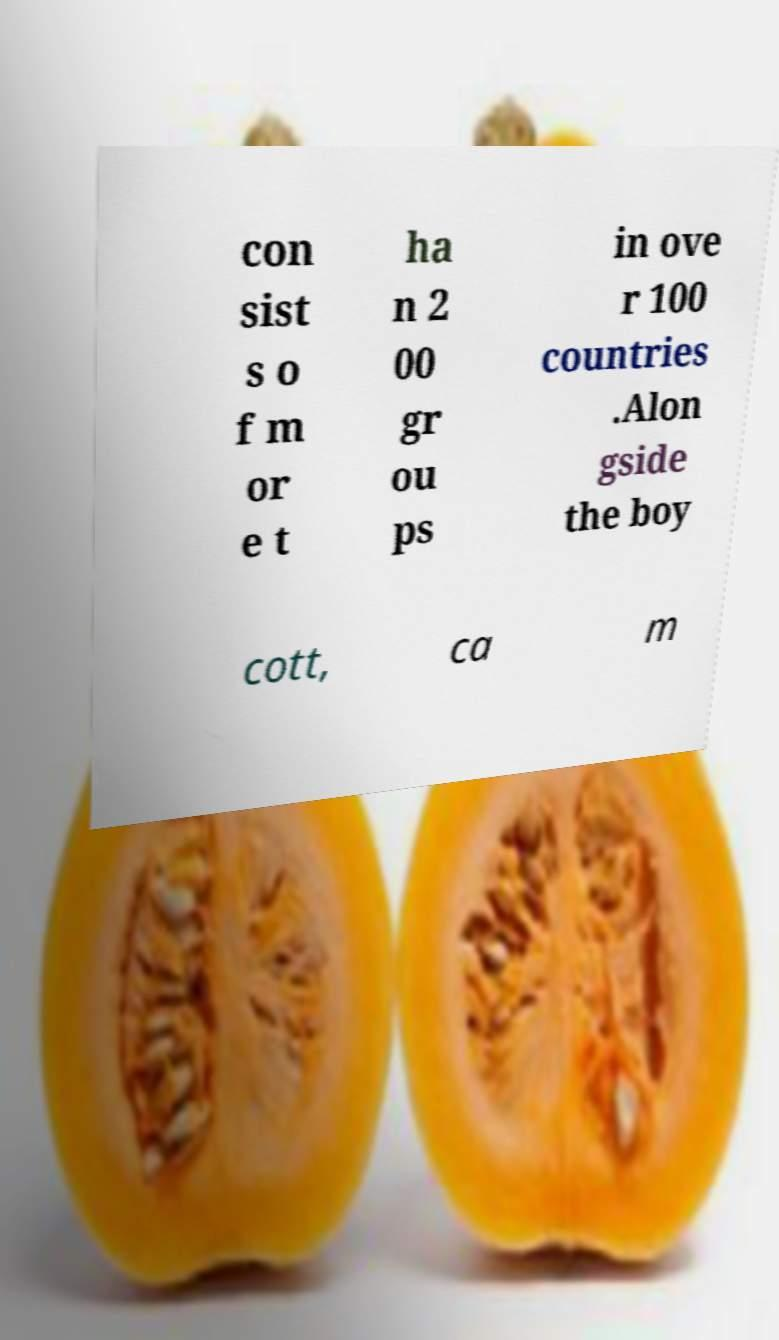I need the written content from this picture converted into text. Can you do that? con sist s o f m or e t ha n 2 00 gr ou ps in ove r 100 countries .Alon gside the boy cott, ca m 